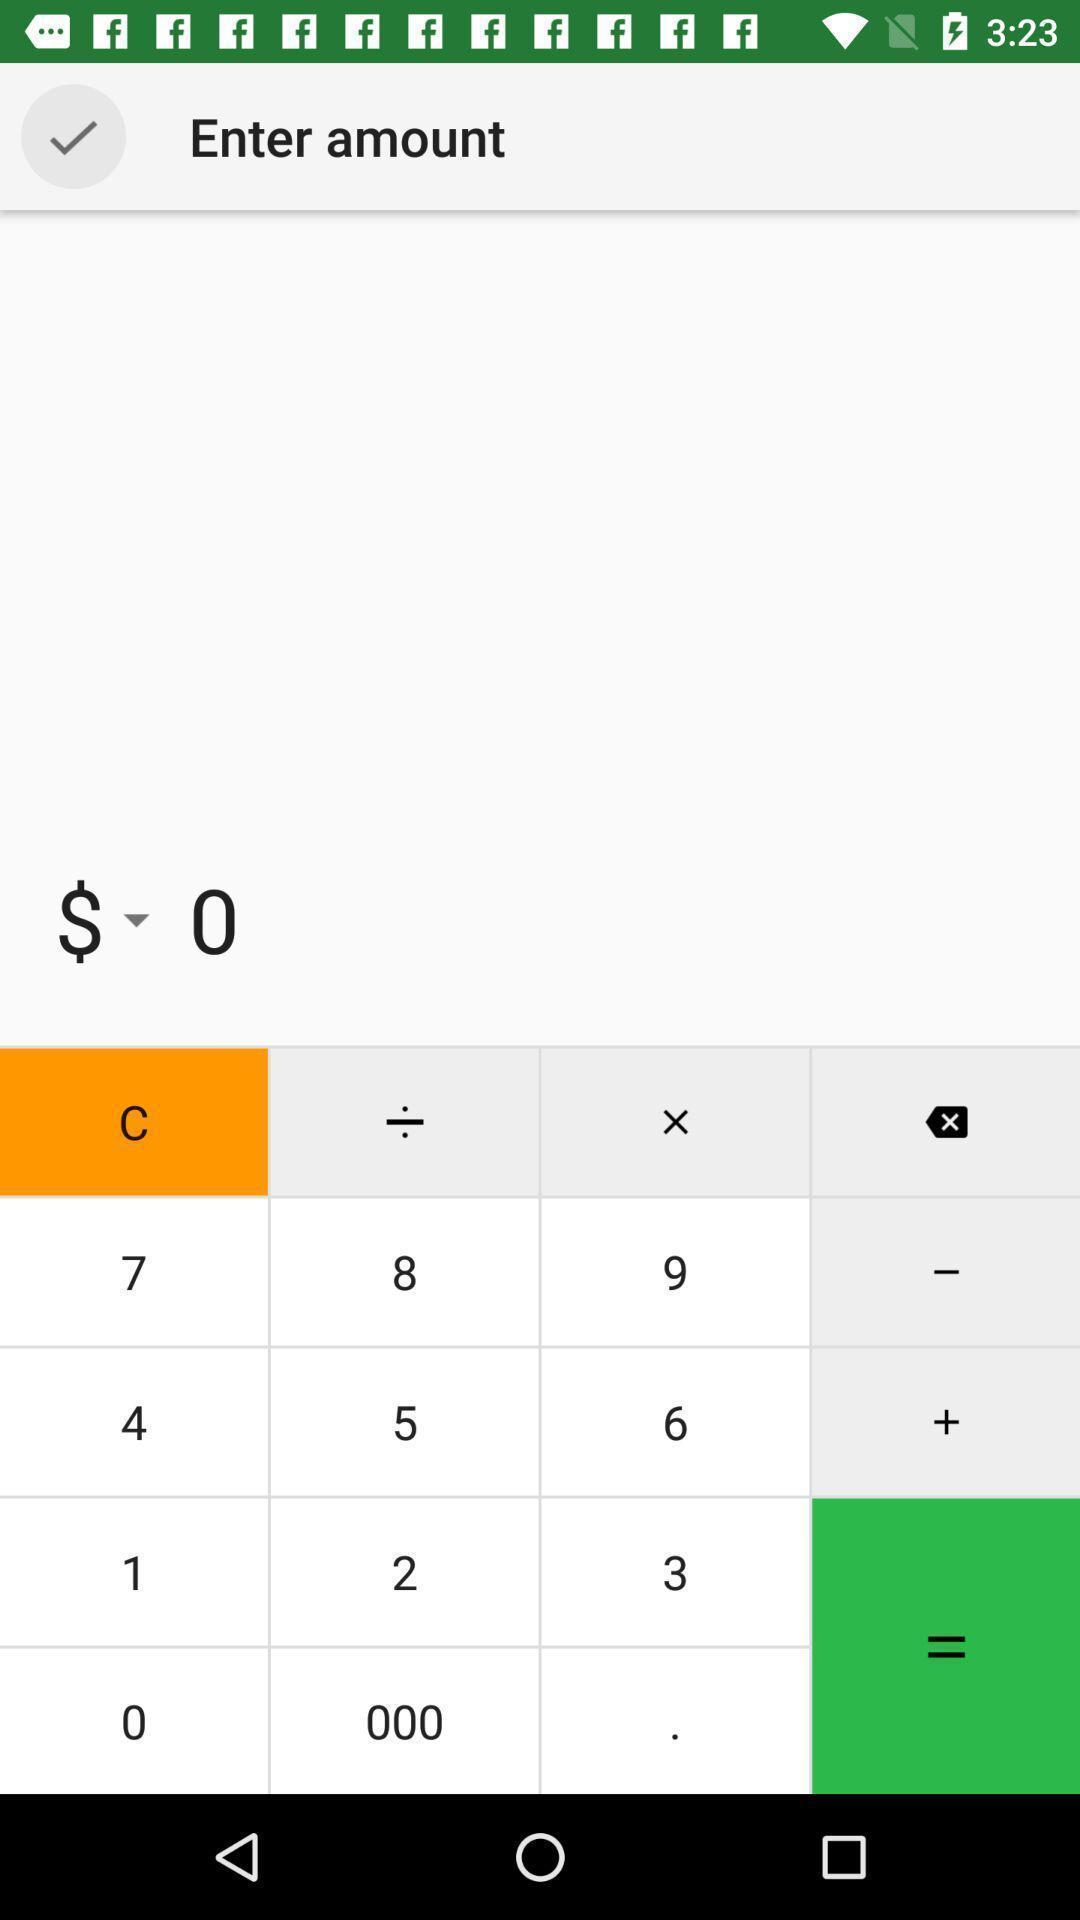Give me a narrative description of this picture. Screen showing a calculator asking to enter amount. 